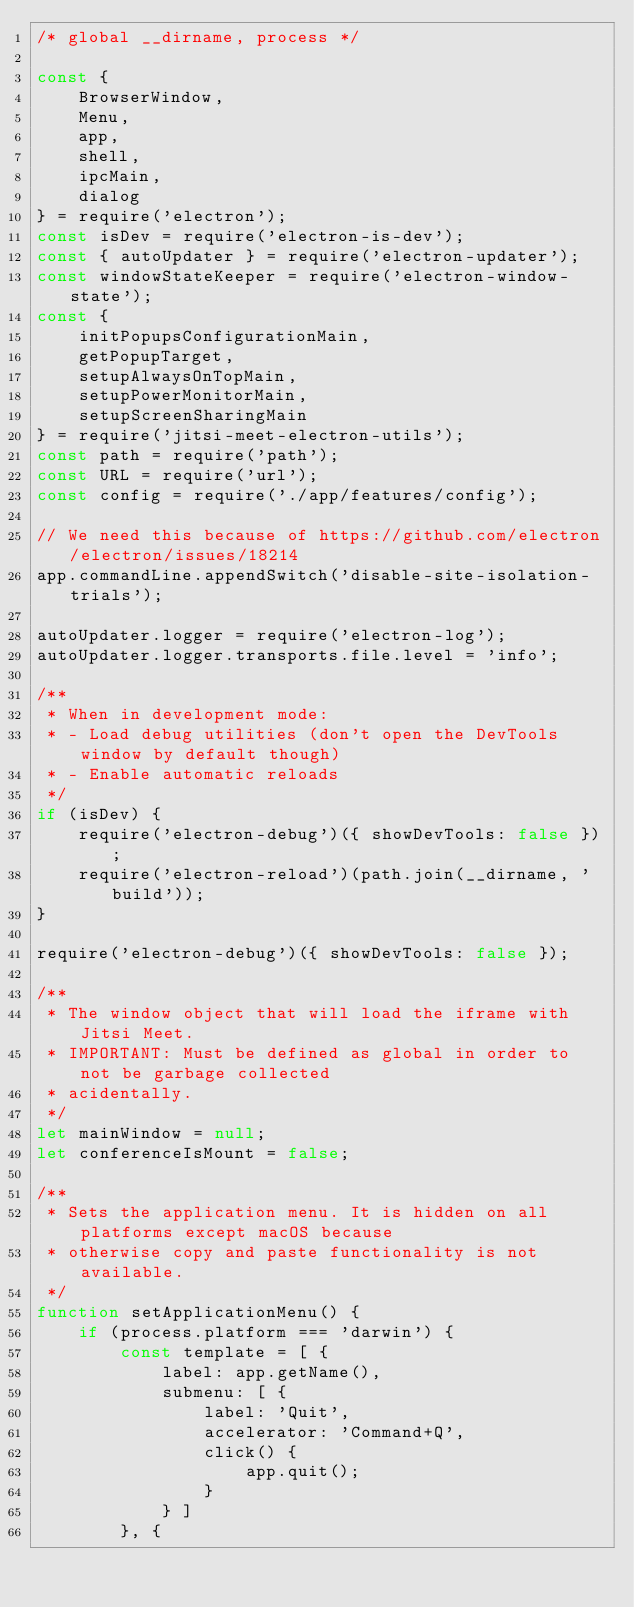Convert code to text. <code><loc_0><loc_0><loc_500><loc_500><_JavaScript_>/* global __dirname, process */

const {
    BrowserWindow,
    Menu,
    app,
    shell,
    ipcMain,
    dialog
} = require('electron');
const isDev = require('electron-is-dev');
const { autoUpdater } = require('electron-updater');
const windowStateKeeper = require('electron-window-state');
const {
    initPopupsConfigurationMain,
    getPopupTarget,
    setupAlwaysOnTopMain,
    setupPowerMonitorMain,
    setupScreenSharingMain
} = require('jitsi-meet-electron-utils');
const path = require('path');
const URL = require('url');
const config = require('./app/features/config');

// We need this because of https://github.com/electron/electron/issues/18214
app.commandLine.appendSwitch('disable-site-isolation-trials');

autoUpdater.logger = require('electron-log');
autoUpdater.logger.transports.file.level = 'info';

/**
 * When in development mode:
 * - Load debug utilities (don't open the DevTools window by default though)
 * - Enable automatic reloads
 */
if (isDev) {
    require('electron-debug')({ showDevTools: false });
    require('electron-reload')(path.join(__dirname, 'build'));
}

require('electron-debug')({ showDevTools: false });

/**
 * The window object that will load the iframe with Jitsi Meet.
 * IMPORTANT: Must be defined as global in order to not be garbage collected
 * acidentally.
 */
let mainWindow = null;
let conferenceIsMount = false;

/**
 * Sets the application menu. It is hidden on all platforms except macOS because
 * otherwise copy and paste functionality is not available.
 */
function setApplicationMenu() {
    if (process.platform === 'darwin') {
        const template = [ {
            label: app.getName(),
            submenu: [ {
                label: 'Quit',
                accelerator: 'Command+Q',
                click() {
                    app.quit();
                }
            } ]
        }, {</code> 